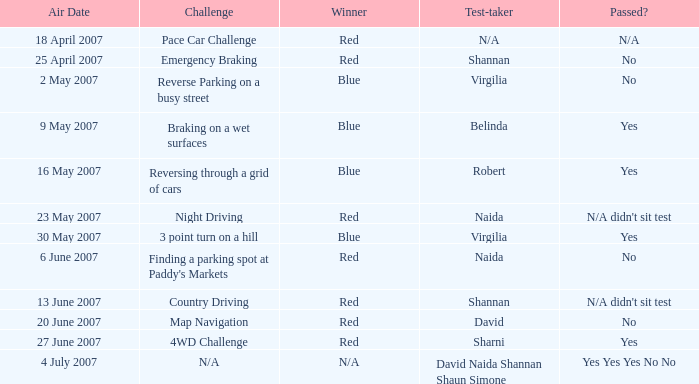What is the result for passing in the country driving challenge? N/A didn't sit test. 